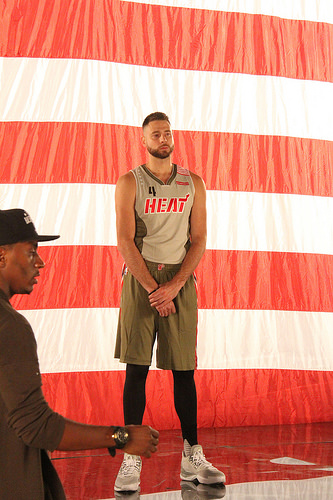<image>
Can you confirm if the shoe is on the man? No. The shoe is not positioned on the man. They may be near each other, but the shoe is not supported by or resting on top of the man. 